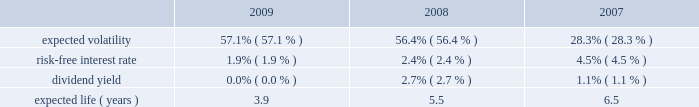Insurance arrangement .
As a result of the adoption of this new guidance , the company recorded a liability representing the actuarial present value of the future death benefits as of the employees 2019 expected retirement date of $ 45 million with the offset reflected as a cumulative-effect adjustment to january 1 , 2008 retained earnings and accumulated other comprehensive income ( loss ) in the amounts of $ 4 million and $ 41 million , respectively , in the company 2019s consolidated statement of stockholders 2019 equity .
It is currently expected that minimal , if any , further cash payments will be required to fund these policies .
The net periodic cost for these split-dollar life insurance arrangements was $ 6 million in both the years ended december 31 , 2009 and 2008 .
The company has recorded a liability representing the actuarial present value of the future death benefits as of the employees 2019 expected retirement date of $ 48 million and $ 47 million as of december 31 , 2009 and december 31 , 2008 , respectively .
Defined contribution plan the company and certain subsidiaries have various defined contribution plans , in which all eligible employees participate .
In the u.s. , the 401 ( k ) plan is a contributory plan .
Matching contributions are based upon the amount of the employees 2019 contributions .
Effective january 1 , 2005 , newly hired employees have a higher maximum matching contribution at 4% ( 4 % ) on the first 5% ( 5 % ) of employee contributions , compared to 3% ( 3 % ) on the first 6% ( 6 % ) of employee contributions for employees hired prior to january 2005 .
Effective january 1 , 2009 , the company temporarily suspended all matching contributions to the motorola 401 ( k ) plan .
The company 2019s expenses , primarily relating to the employer match , for all defined contribution plans , for the years ended december 31 , 2009 , 2008 and 2007 were $ 8 million , $ 95 million and $ 116 million , respectively .
Share-based compensation plans and other incentive plans stock options , stock appreciation rights and employee stock purchase plan the company grants options to acquire shares of common stock to certain employees , and existing option holders in connection with the merging of option plans following an acquisition .
Each option granted and stock appreciation right has an exercise price of no less than 100% ( 100 % ) of the fair market value of the common stock on the date of the grant .
The awards have a contractual life of five to ten years and vest over two to four years .
Stock options and stock appreciation rights assumed or replaced with comparable stock options or stock appreciation rights in conjunction with a change in control only become exercisable if the holder is also involuntarily terminated ( for a reason other than cause ) or quits for good reason within 24 months of a change in control .
The employee stock purchase plan allows eligible participants to purchase shares of the company 2019s common stock through payroll deductions of up to 10% ( 10 % ) of eligible compensation on an after-tax basis .
Plan participants cannot purchase more than $ 25000 of stock in any calendar year .
The price an employee pays per share is 85% ( 85 % ) of the lower of the fair market value of the company 2019s stock on the close of the first trading day or last trading day of the purchase period .
The plan has two purchase periods , the first one from october 1 through march 31 and the second one from april 1 through september 30 .
For the years ended december 31 , 2009 , 2008 and 2007 , employees purchased 29.4 million , 18.9 million and 10.2 million shares , respectively , at purchase prices of $ 3.60 and $ 3.68 , $ 7.91 and $ 6.07 , and $ 14.93 and $ 15.02 , respectively .
The company calculates the value of each employee stock option , estimated on the date of grant , using the black-scholes option pricing model .
The weighted-average estimated fair value of employee stock options granted during 2009 , 2008 and 2007 was $ 2.78 , $ 3.47 and $ 5.95 , respectively , using the following weighted-average assumptions : 2009 2008 2007 .

What is the percent change in number of shares purchased by employees between 2008 and 2009? 
Computations: ((29.4 - 18.9) / 18.9)
Answer: 0.55556. Insurance arrangement .
As a result of the adoption of this new guidance , the company recorded a liability representing the actuarial present value of the future death benefits as of the employees 2019 expected retirement date of $ 45 million with the offset reflected as a cumulative-effect adjustment to january 1 , 2008 retained earnings and accumulated other comprehensive income ( loss ) in the amounts of $ 4 million and $ 41 million , respectively , in the company 2019s consolidated statement of stockholders 2019 equity .
It is currently expected that minimal , if any , further cash payments will be required to fund these policies .
The net periodic cost for these split-dollar life insurance arrangements was $ 6 million in both the years ended december 31 , 2009 and 2008 .
The company has recorded a liability representing the actuarial present value of the future death benefits as of the employees 2019 expected retirement date of $ 48 million and $ 47 million as of december 31 , 2009 and december 31 , 2008 , respectively .
Defined contribution plan the company and certain subsidiaries have various defined contribution plans , in which all eligible employees participate .
In the u.s. , the 401 ( k ) plan is a contributory plan .
Matching contributions are based upon the amount of the employees 2019 contributions .
Effective january 1 , 2005 , newly hired employees have a higher maximum matching contribution at 4% ( 4 % ) on the first 5% ( 5 % ) of employee contributions , compared to 3% ( 3 % ) on the first 6% ( 6 % ) of employee contributions for employees hired prior to january 2005 .
Effective january 1 , 2009 , the company temporarily suspended all matching contributions to the motorola 401 ( k ) plan .
The company 2019s expenses , primarily relating to the employer match , for all defined contribution plans , for the years ended december 31 , 2009 , 2008 and 2007 were $ 8 million , $ 95 million and $ 116 million , respectively .
Share-based compensation plans and other incentive plans stock options , stock appreciation rights and employee stock purchase plan the company grants options to acquire shares of common stock to certain employees , and existing option holders in connection with the merging of option plans following an acquisition .
Each option granted and stock appreciation right has an exercise price of no less than 100% ( 100 % ) of the fair market value of the common stock on the date of the grant .
The awards have a contractual life of five to ten years and vest over two to four years .
Stock options and stock appreciation rights assumed or replaced with comparable stock options or stock appreciation rights in conjunction with a change in control only become exercisable if the holder is also involuntarily terminated ( for a reason other than cause ) or quits for good reason within 24 months of a change in control .
The employee stock purchase plan allows eligible participants to purchase shares of the company 2019s common stock through payroll deductions of up to 10% ( 10 % ) of eligible compensation on an after-tax basis .
Plan participants cannot purchase more than $ 25000 of stock in any calendar year .
The price an employee pays per share is 85% ( 85 % ) of the lower of the fair market value of the company 2019s stock on the close of the first trading day or last trading day of the purchase period .
The plan has two purchase periods , the first one from october 1 through march 31 and the second one from april 1 through september 30 .
For the years ended december 31 , 2009 , 2008 and 2007 , employees purchased 29.4 million , 18.9 million and 10.2 million shares , respectively , at purchase prices of $ 3.60 and $ 3.68 , $ 7.91 and $ 6.07 , and $ 14.93 and $ 15.02 , respectively .
The company calculates the value of each employee stock option , estimated on the date of grant , using the black-scholes option pricing model .
The weighted-average estimated fair value of employee stock options granted during 2009 , 2008 and 2007 was $ 2.78 , $ 3.47 and $ 5.95 , respectively , using the following weighted-average assumptions : 2009 2008 2007 .

What was the average company 2019s expenses , primarily relating to the employer match from 2007 to 2009 for all defined contribution plans in millions? 
Computations: ((((8 + 95) + 116) + 3) / 2)
Answer: 111.0. Insurance arrangement .
As a result of the adoption of this new guidance , the company recorded a liability representing the actuarial present value of the future death benefits as of the employees 2019 expected retirement date of $ 45 million with the offset reflected as a cumulative-effect adjustment to january 1 , 2008 retained earnings and accumulated other comprehensive income ( loss ) in the amounts of $ 4 million and $ 41 million , respectively , in the company 2019s consolidated statement of stockholders 2019 equity .
It is currently expected that minimal , if any , further cash payments will be required to fund these policies .
The net periodic cost for these split-dollar life insurance arrangements was $ 6 million in both the years ended december 31 , 2009 and 2008 .
The company has recorded a liability representing the actuarial present value of the future death benefits as of the employees 2019 expected retirement date of $ 48 million and $ 47 million as of december 31 , 2009 and december 31 , 2008 , respectively .
Defined contribution plan the company and certain subsidiaries have various defined contribution plans , in which all eligible employees participate .
In the u.s. , the 401 ( k ) plan is a contributory plan .
Matching contributions are based upon the amount of the employees 2019 contributions .
Effective january 1 , 2005 , newly hired employees have a higher maximum matching contribution at 4% ( 4 % ) on the first 5% ( 5 % ) of employee contributions , compared to 3% ( 3 % ) on the first 6% ( 6 % ) of employee contributions for employees hired prior to january 2005 .
Effective january 1 , 2009 , the company temporarily suspended all matching contributions to the motorola 401 ( k ) plan .
The company 2019s expenses , primarily relating to the employer match , for all defined contribution plans , for the years ended december 31 , 2009 , 2008 and 2007 were $ 8 million , $ 95 million and $ 116 million , respectively .
Share-based compensation plans and other incentive plans stock options , stock appreciation rights and employee stock purchase plan the company grants options to acquire shares of common stock to certain employees , and existing option holders in connection with the merging of option plans following an acquisition .
Each option granted and stock appreciation right has an exercise price of no less than 100% ( 100 % ) of the fair market value of the common stock on the date of the grant .
The awards have a contractual life of five to ten years and vest over two to four years .
Stock options and stock appreciation rights assumed or replaced with comparable stock options or stock appreciation rights in conjunction with a change in control only become exercisable if the holder is also involuntarily terminated ( for a reason other than cause ) or quits for good reason within 24 months of a change in control .
The employee stock purchase plan allows eligible participants to purchase shares of the company 2019s common stock through payroll deductions of up to 10% ( 10 % ) of eligible compensation on an after-tax basis .
Plan participants cannot purchase more than $ 25000 of stock in any calendar year .
The price an employee pays per share is 85% ( 85 % ) of the lower of the fair market value of the company 2019s stock on the close of the first trading day or last trading day of the purchase period .
The plan has two purchase periods , the first one from october 1 through march 31 and the second one from april 1 through september 30 .
For the years ended december 31 , 2009 , 2008 and 2007 , employees purchased 29.4 million , 18.9 million and 10.2 million shares , respectively , at purchase prices of $ 3.60 and $ 3.68 , $ 7.91 and $ 6.07 , and $ 14.93 and $ 15.02 , respectively .
The company calculates the value of each employee stock option , estimated on the date of grant , using the black-scholes option pricing model .
The weighted-average estimated fair value of employee stock options granted during 2009 , 2008 and 2007 was $ 2.78 , $ 3.47 and $ 5.95 , respectively , using the following weighted-average assumptions : 2009 2008 2007 .

What is the percent change in weighted-average estimated fair value of employee stock options between 2007 and 2008? 
Computations: ((3.47 - 5.95) / 5.95)
Answer: -0.41681. 